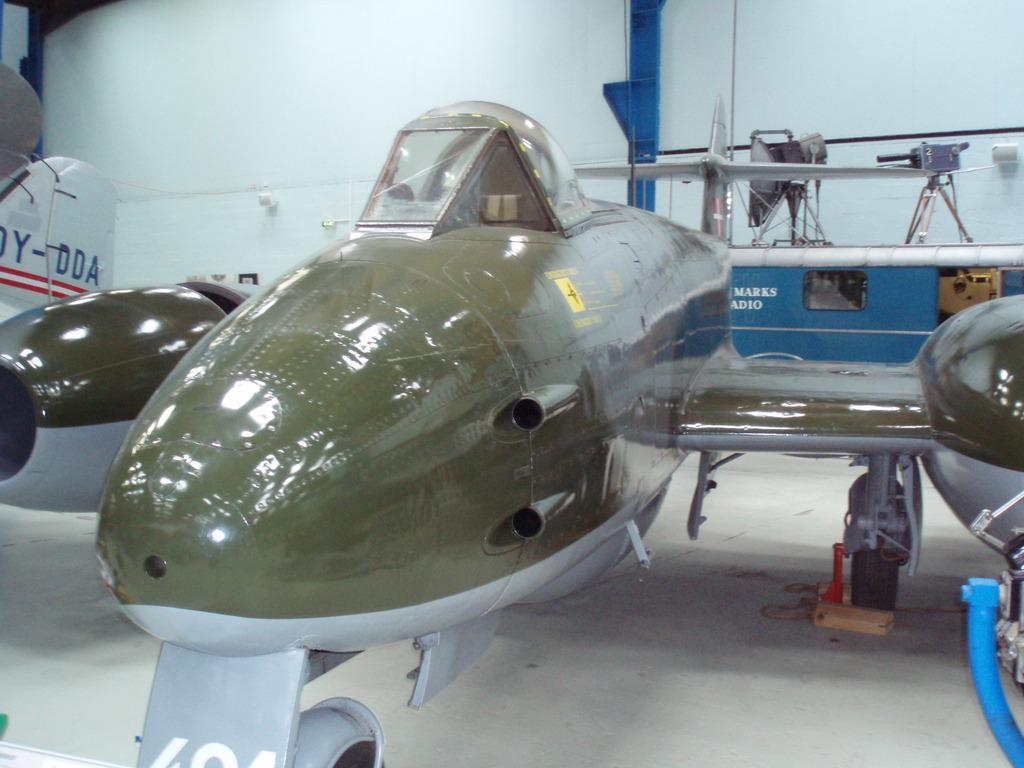<image>
Summarize the visual content of the image. Old war planes sit on display with markings such as Marks Adio written on them. 